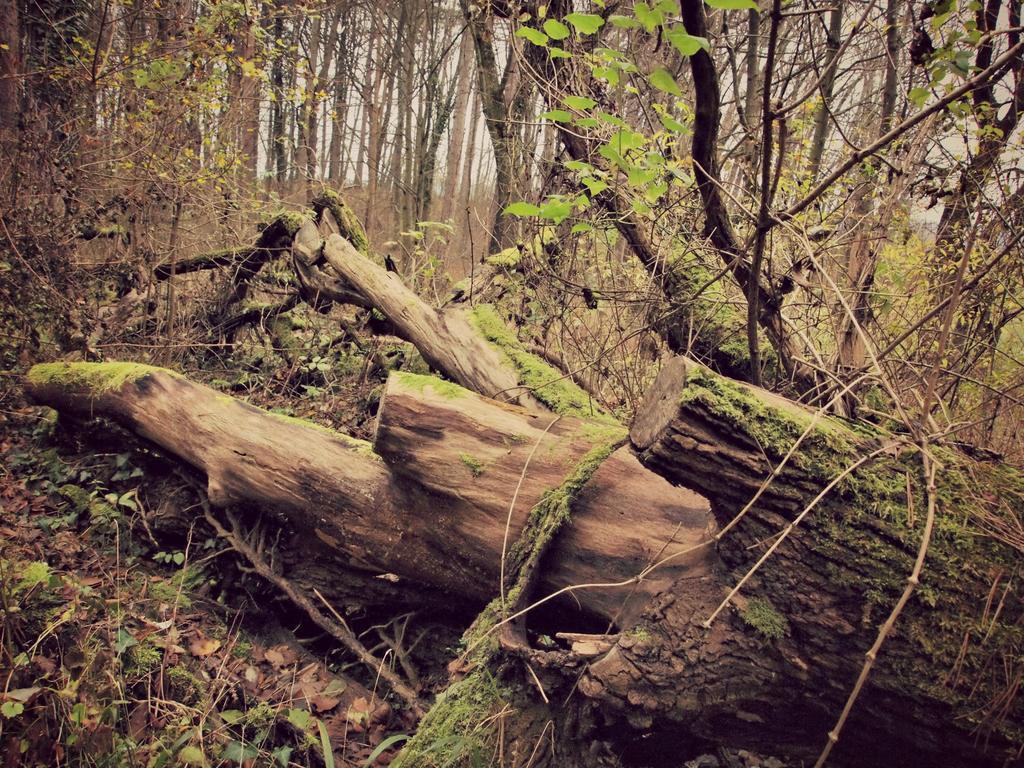How would you summarize this image in a sentence or two? This picture is clicked outside the city. In the foreground we can see the trunks of the trees lying on the ground. In the background we can see the trees and the plants. 